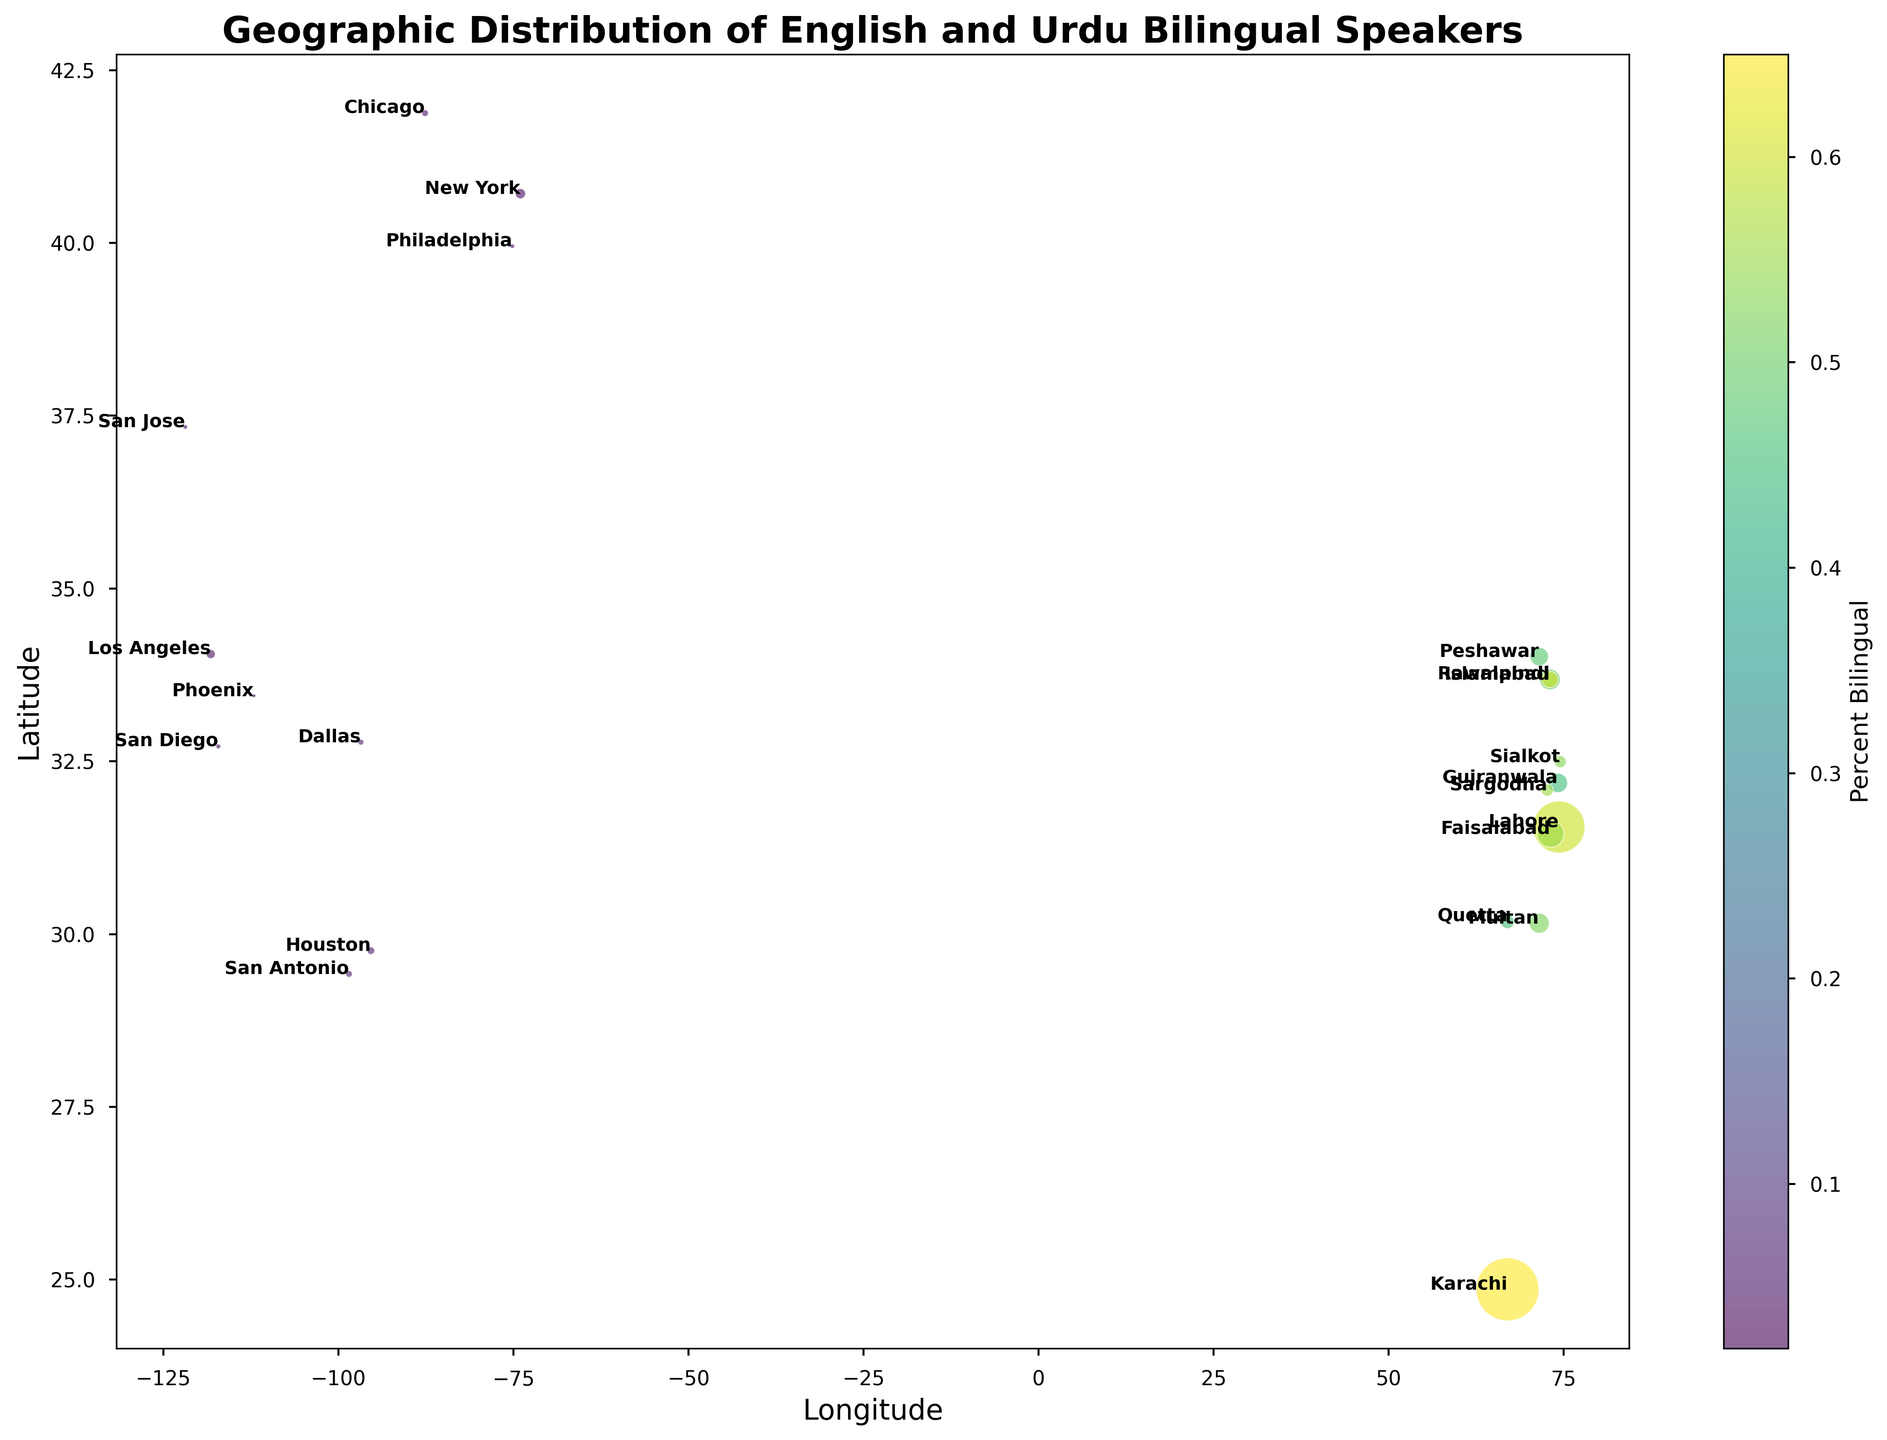Which region has the highest percentage of English and Urdu bilingual speakers? By examining the color gradient in the color bar, we identify Karachi with the highest percentage of bilingual speakers given by the darker color shade.
Answer: Karachi Which city in the US has the largest population of bilingual speakers? We need to identify the largest bubble among US cities. On close inspection, Houston's bubble is the largest, denoting the largest population of bilingual speakers.
Answer: Houston What are the coordinates of Lahore on the plot? Locate Lahore on the chart, check its longitude and latitude labels placed near the bubble. Lahore's coordinates are at 31.5497 latitude and 74.3436 longitude.
Answer: 31.5497, 74.3436 Which two cities have equal percentages of bilingual speakers in Pakistan and the US respectively? Identify cities with equal color intensity. Islamabad and Philadelphia both share a similar medium shade indicating 60% and 3% bilingual speakers respectively; however, Sargodha and Chicago have equal percentages of 55% and 4% respectively.
Answer: Sargodha and Chicago Compare the percentage of bilingual speakers between Karachi and New York. Which is higher? Compare the color intensity of the bubbles representing Karachi and New York. Karachi's bubble has a darker intensity (higher percentage) compared to New York's.
Answer: Karachi Which region in Pakistan has the smallest population and what is its percentage of bilingual speakers? Identify the smallest bubble in Pakistan. Sialkot has the smallest population among Pakistani cities with 53% bilingual speakers as denoted by the color shade.
Answer: Sialkot, 53% Find the average percentage of bilingual speakers in all regions listed in the US. Calculate the average of the given percentages for all US cities: (0.03 + 0.05 + 0.04 + 0.06 + 0.02 + 0.03 + 0.07 + 0.04 + 0.06 + 0.05) / 10 = 0.045 or 4.5%.
Answer: 4.5% Compare Dallas and Houston by their percentage of bilingual speakers and population size. Dallas and Houston have equal bilingual speakers percentages (6%). However, Houston (2,328,000) has a larger population compared to Dallas (1,341,000).
Answer: Houston, larger population Identify the region with the highest latitude in the dataset and its bilingual percentage. Find the point positioned at the highest latitude. Chicago (41.8781 latitude) has the highest latitude with 4% bilingual speakers.
Answer: Chicago, 4% Which region has a close to but lower than 0.50 percentage of bilingual speakers in Pakistan? Look for a region in Pakistan with slightly less than 0.50, indicated by close color intensity to 0.50. Both Peshawar (0.48 or 48%) and Quetta (0.46 or 46%) fall in this range.
Answer: Peshawar, 48% 